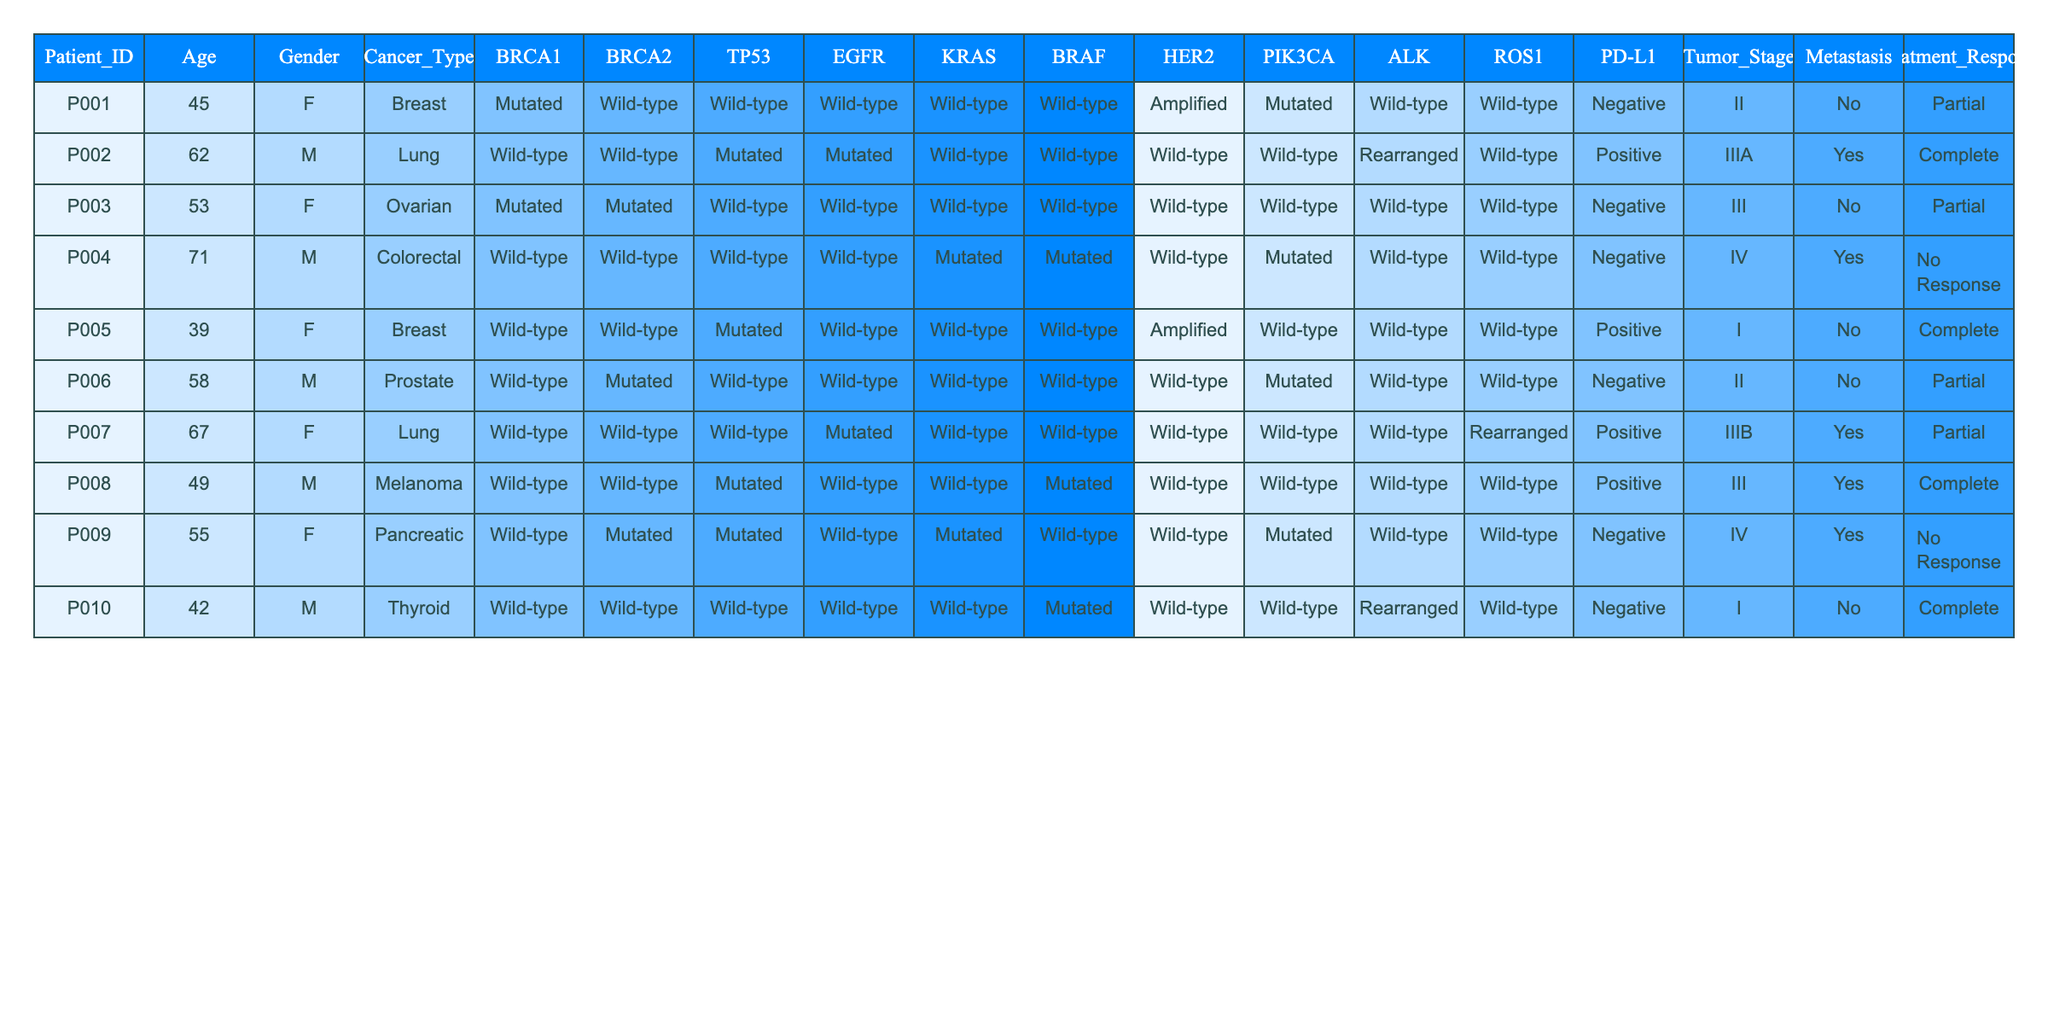What is the age of the oldest patient in the cohort? The ages of the patients are 45, 62, 53, 71, 39, 58, 67, 49, 55, and 42. The maximum age among these values is 71.
Answer: 71 How many patients have the BRCA1 gene mutated? The patients with mutated BRCA1 are P001, P003, P005, and P009, making a total of four patients.
Answer: 4 What is the cancer type for the patient with the lowest tumor stage? The patient with the lowest tumor stage is P010, who has a tumor stage of I. The cancer type for this patient is Thyroid.
Answer: Thyroid Which patients had a complete treatment response? The patients who had a complete treatment response are P002, P005, and P010.
Answer: P002, P005, P010 Is there any patient with lung cancer who also has a mutated TP53 gene? Among the patients with lung cancer, P002 and P007 are present. P002 has mutated TP53, while P007 has a wild-type TP53. Therefore, there is one patient with lung cancer who has a mutated TP53 gene.
Answer: Yes What percentage of patients experienced metastasis? There are 10 patients in total, and 4 of them experienced metastasis. The percentage is (4/10) * 100 = 40%.
Answer: 40% How many patients with breast cancer have mutated HER2? In the cohort, only P001 and P005 are breast cancer patients. P001 has amplified HER2, while P005 has wild-type HER2. Thus, no breast cancer patient has mutated HER2.
Answer: 0 Which cancer type has the highest age average among patients? For lung cancer, patients P002 (62) and P007 (67) are present, giving an average age of (62 + 67) / 2 = 64.5. For breast cancer, we have P001 (45) and P005 (39), with an average age of (45 + 39) / 2 = 42. For other types, similar calculations lead to ovarian (53), colorectal (71), prostate (58), melanoma (49), and pancreatic (55). Lung cancer has the highest average age of 64.5.
Answer: Lung cancer Are there any patients with stage IV cancer who had a negative treatment response? P004 and P009 both have stage IV cancer, where P004 has a negative treatment response. Therefore, there is one patient with stage IV cancer and a negative treatment response.
Answer: Yes What is the common gene alteration found in patients with colorectal cancer? The only colorectal cancer patient is P004. According to the data, P004 has mutated KRAS and mutated BRAF genes. These gene alterations are specific to this patient.
Answer: Mutated KRAS and BRAF 